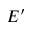<formula> <loc_0><loc_0><loc_500><loc_500>E ^ { \prime }</formula> 